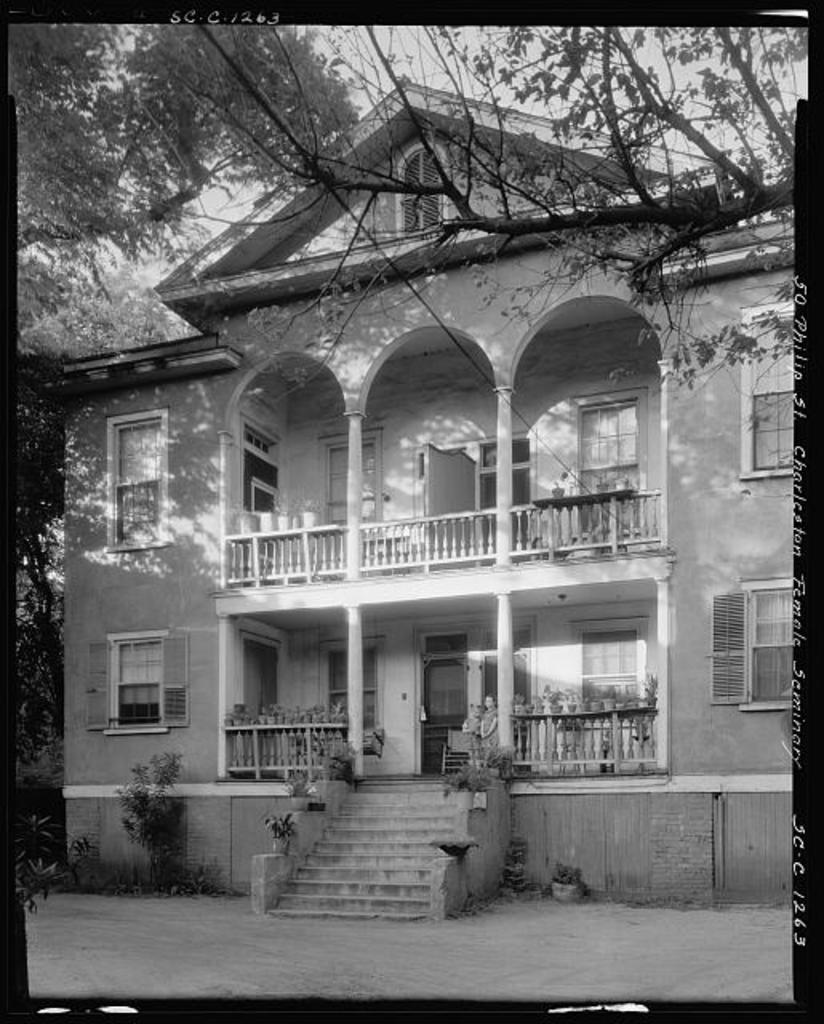What type of structure is visible in the image? There is a building in the image. What other natural elements can be seen in the image? There are trees and plants in the image. What architectural feature is present at the bottom of the image? There are stairs at the bottom of the image. What is visible at the top of the image? The sky is visible at the top of the image. What historical event is depicted in the frame of the image? There is no frame present in the image, and no historical event is depicted. 